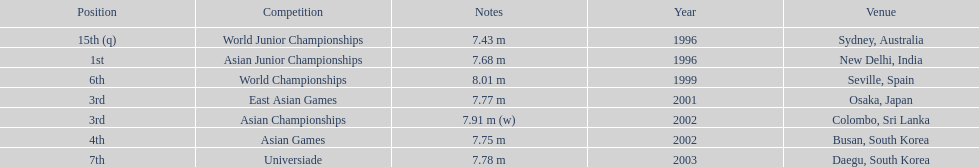Which year was his best jump? 1999. 